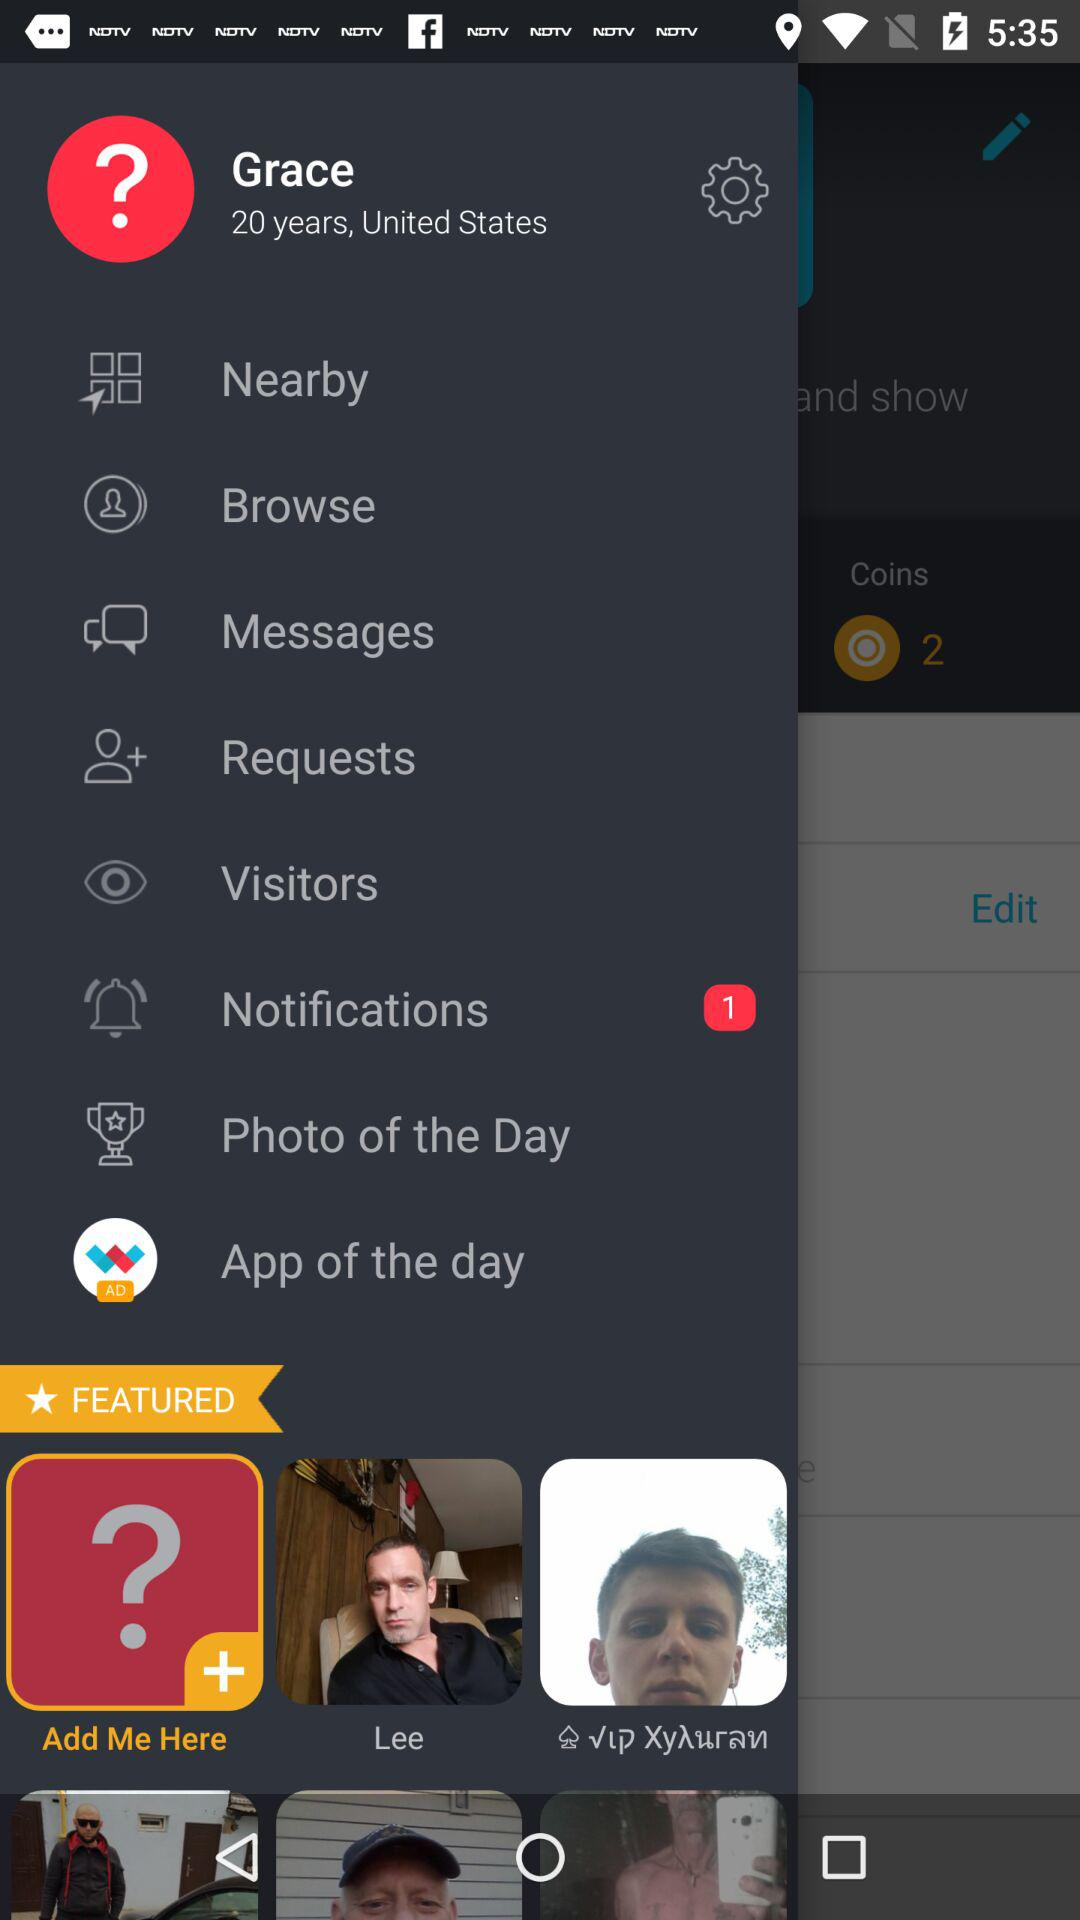Where does Grace live? Grace lives in the United States. 